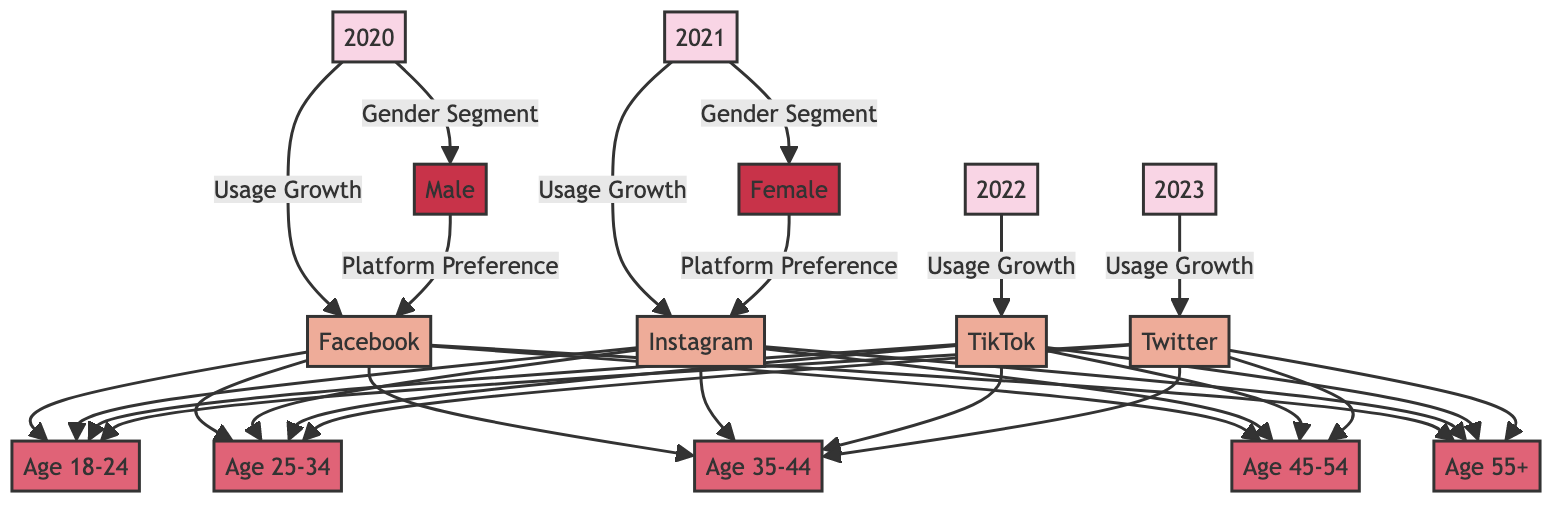What age group is represented in the node for 2020? The node for 2020 connects to Facebook, which further branches out to multiple age groups. Each age group is represented in the same level with Facebook being the connecting node. Since the specific age groups are connected to Facebook, it can be inferred that they are part of the year 2020's usage data.
Answer: 18-24, 25-34, 35-44, 45-54, 55+ Which platform had the highest growth in 2022? The diagram indicates platform usage growth over the years. The arrow connecting 2022 to TikTok signifies that in 2022, TikTok experienced growth, while the connections to other platforms do not specify growth for this year. Thus, TikTok is the only platform noted for growth in 2022 according to the diagram.
Answer: TikTok How many age groups are represented in the diagram? Each platform is connected to the same five age groups (18-24, 25-34, 35-44, 45-54, 55+), and since all platforms share these age demographics, we can simply count the distinct age groups listed by examining their connections. As there are five shown, the total number of age groups represented is five.
Answer: 5 Which gender is indicated to prefer Facebook according to the diagram? The gender segment in 2020 directly links to the platform Facebook, which suggests that this gender is the targeted user base for that platform primarily in that year. It can be observed from the connection leading to Facebook that the male population has a preference for this platform as depicted in the diagram.
Answer: Male In which year did Twitter show usage growth according to the diagram? The direct connection from the year 2023 to Twitter clearly indicates that this was the year Twitter experienced growth, as indicated by the arrow from the year node to the platform node. This means that 2023 is the year Twitter is associated with increased usage.
Answer: 2023 What is the primary platform preference for females indicated in the diagram? The diagram shows a connection in 2021 from the female gender node leading to Instagram. This direct linkage presents Instagram as the preferred platform for females in that year, thus indicating their choice distinctly in the visual representation.
Answer: Instagram Which age demographic is explicitly indicated in the usage growth for Instagram? The nodes connected to Instagram show the corresponding age demographics that are represented in the diagram. Each age group below Instagram represents users from that specific demographic that have shown growth, thus each of the listed age groups (18-24, 25-34, 35-44, 45-54, 55+) fall under this category.
Answer: 18-24, 25-34, 35-44, 45-54, 55+ Which year's data is represented for both genders in the diagram? The diagram shows distinct gender segments with connections to platforms for two specific years: 2020 for males and 2021 for females. Since there are no other years represented in the same manner for both genders, it indicates those two years are reflected distinctly for male and female demographics in social media platform preferences.
Answer: 2020 and 2021 